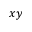Convert formula to latex. <formula><loc_0><loc_0><loc_500><loc_500>x y</formula> 